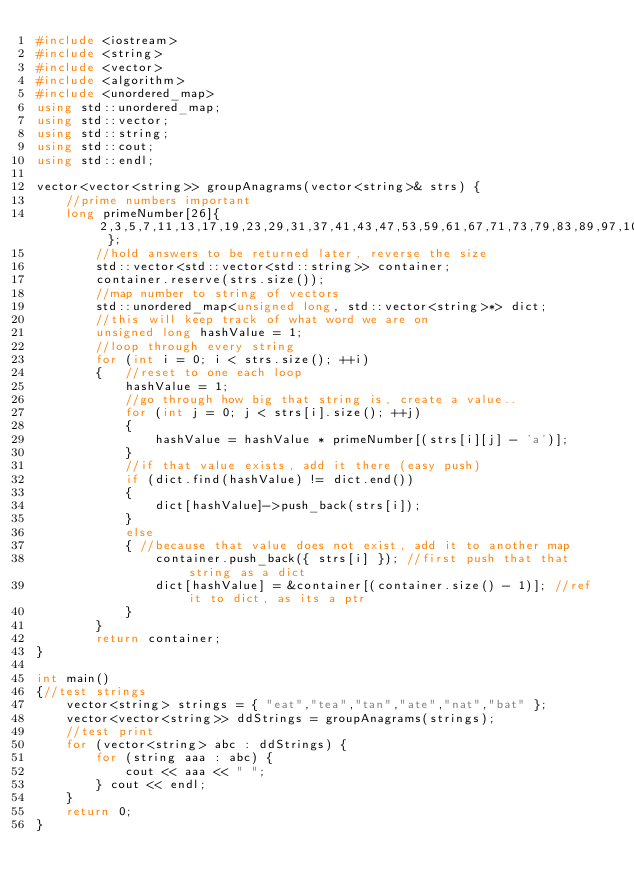Convert code to text. <code><loc_0><loc_0><loc_500><loc_500><_C++_>#include <iostream>
#include <string>
#include <vector>
#include <algorithm> 
#include <unordered_map>
using std::unordered_map;
using std::vector;
using std::string;
using std::cout; 
using std::endl;

vector<vector<string>> groupAnagrams(vector<string>& strs) {
	//prime numbers important
	long primeNumber[26]{ 2,3,5,7,11,13,17,19,23,29,31,37,41,43,47,53,59,61,67,71,73,79,83,89,97,101 };
		//hold answers to be returned later, reverse the size
		std::vector<std::vector<std::string>> container;
		container.reserve(strs.size());
		//map number to string of vectors
		std::unordered_map<unsigned long, std::vector<string>*> dict;
		//this will keep track of what word we are on
		unsigned long hashValue = 1;
		//loop through every string
		for (int i = 0; i < strs.size(); ++i)
		{   //reset to one each loop
			hashValue = 1;
			//go through how big that string is, create a value..
			for (int j = 0; j < strs[i].size(); ++j)
			{
				hashValue = hashValue * primeNumber[(strs[i][j] - 'a')];
			}
			//if that value exists, add it there (easy push)
			if (dict.find(hashValue) != dict.end())
			{
				dict[hashValue]->push_back(strs[i]);
			}
			else
			{ //because that value does not exist, add it to another map
				container.push_back({ strs[i] }); //first push that that string as a dict
				dict[hashValue] = &container[(container.size() - 1)]; //ref it to dict, as its a ptr
			}
		}
		return container;
}

int main()
{//test strings
	vector<string> strings = { "eat","tea","tan","ate","nat","bat" };
	vector<vector<string>> ddStrings = groupAnagrams(strings);
	//test print
	for (vector<string> abc : ddStrings) {
		for (string aaa : abc) {
			cout << aaa << " ";
		} cout << endl;
	}
	return 0;
}
</code> 